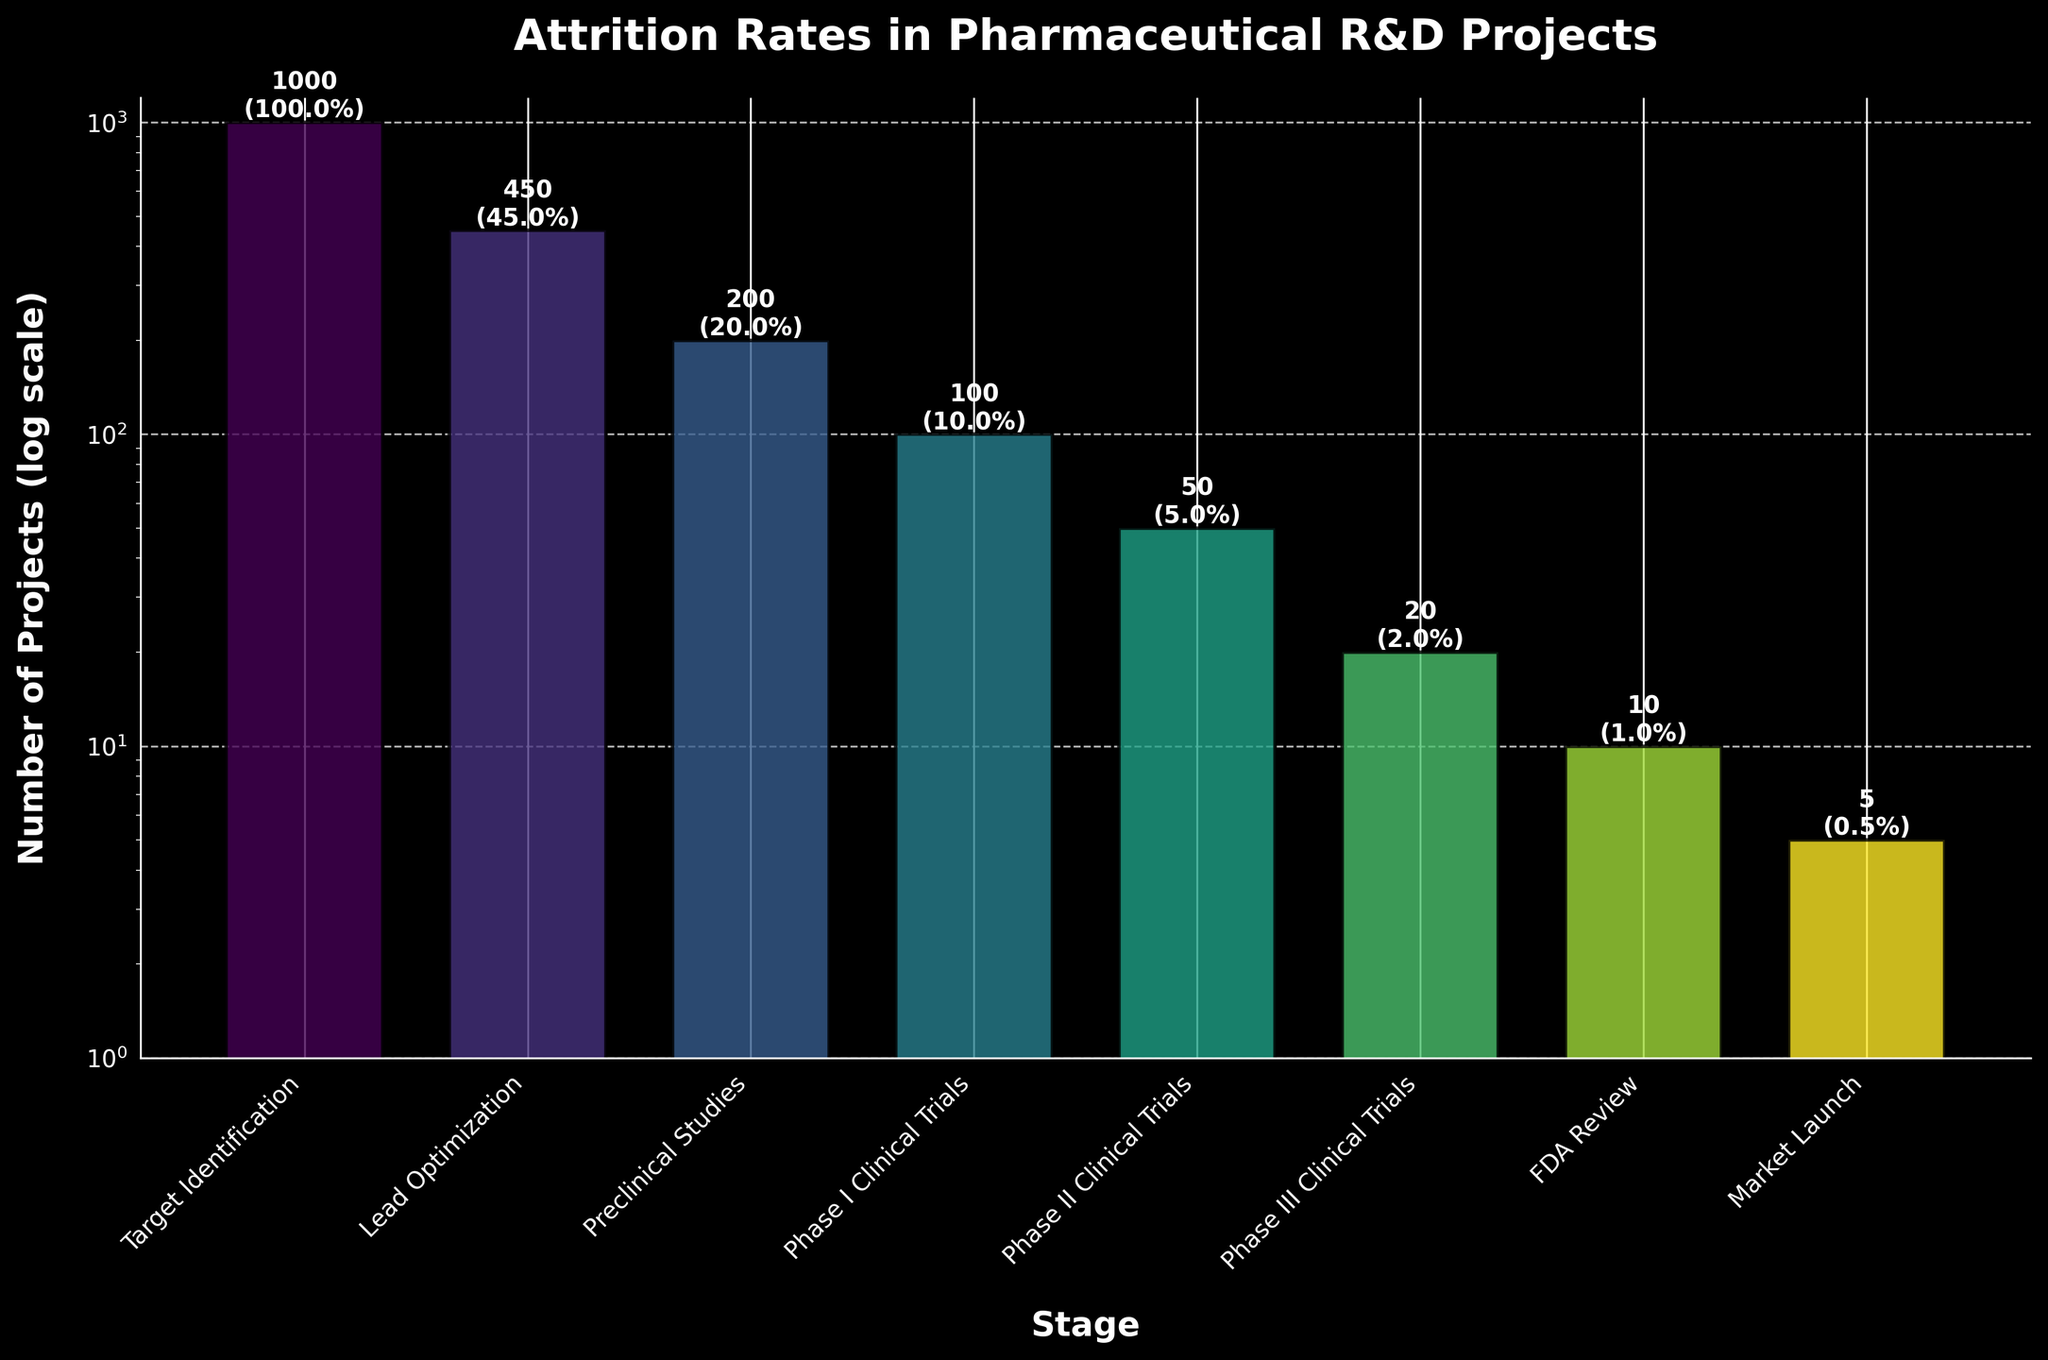What is the title of the figure? The title of the figure is found at the top and is usually descriptive of the data being represented. In this case, it describes the attrition rates at each stage of pharmaceutical R&D projects.
Answer: Attrition Rates in Pharmaceutical R&D Projects Which stage has the highest number of projects? To determine this, look at the bar corresponding to the maximum height on the y-axis. Each bar represents the number of projects in a given stage.
Answer: Target Identification What is the percentage of projects that reach the Market Launch stage? This percentage is labeled directly on the bar for the Market Launch stage. It helps to observe the text annotations on the figure.
Answer: 0.5% How many projects move from Phase II Clinical Trials to Phase III Clinical Trials? By comparing the heights of the bars and the labels for the Phase II and Phase III Clinical Trials stages, we can determine the number of projects at each stage. Subtraction provides the number of projects that do not move forward.
Answer: 30 What is the total drop in project numbers from Target Identification to Preclinical Studies? To find this, subtract the number of projects in Preclinical Studies from those in Target Identification. Specifically, it is 1000 projects in Target Identification minus 200 projects in Preclinical Studies.
Answer: 800 Which stage sees the highest percentage drop in projects compared to the previous stage? Calculate the percentage decrease between consecutive stages. Compare these percentage drops to find the maximum. For example, from Target Identification to Lead Optimization, the drop is (1000-450)/1000 = 55%. Repeat this for each stage transition.
Answer: Lead Optimization At which stage do project numbers fall below 100 for the first time? Look at the stages sequentially to find when the bar height first goes below the 100 project mark.
Answer: Phase II Clinical Trials What is the ratio of projects in Phase I Clinical Trials compared to those in Preclinical Studies? Calculate the ratio by dividing the number of projects in Phase I Clinical Trials (100) by those in Preclinical Studies (200).
Answer: 0.5 Estimate the average percentage of projects that continue through each stage. Sum the percentages at each stage and divide by the number of stages to find the arithmetic average percentage. (100% + 45% + 20% + 10% + 5% + 2% + 1% + 0.5%) / 8
Answer: 22.06% Why is the y-axis on a log scale and how does it help in interpreting this figure? The log scale is used to accommodate the wide range of project numbers, allowing smaller counts to be visible alongside larger counts without distortion. This helps in better visual comparison of values that span several orders of magnitude.
Answer: To handle wide range vizualization 